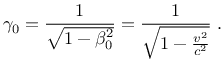<formula> <loc_0><loc_0><loc_500><loc_500>\gamma _ { 0 } = \frac { 1 } { \sqrt { 1 - \beta _ { 0 } ^ { 2 } } } = \frac { 1 } { \sqrt { 1 - \frac { v ^ { 2 } } { c ^ { 2 } } } } \, .</formula> 